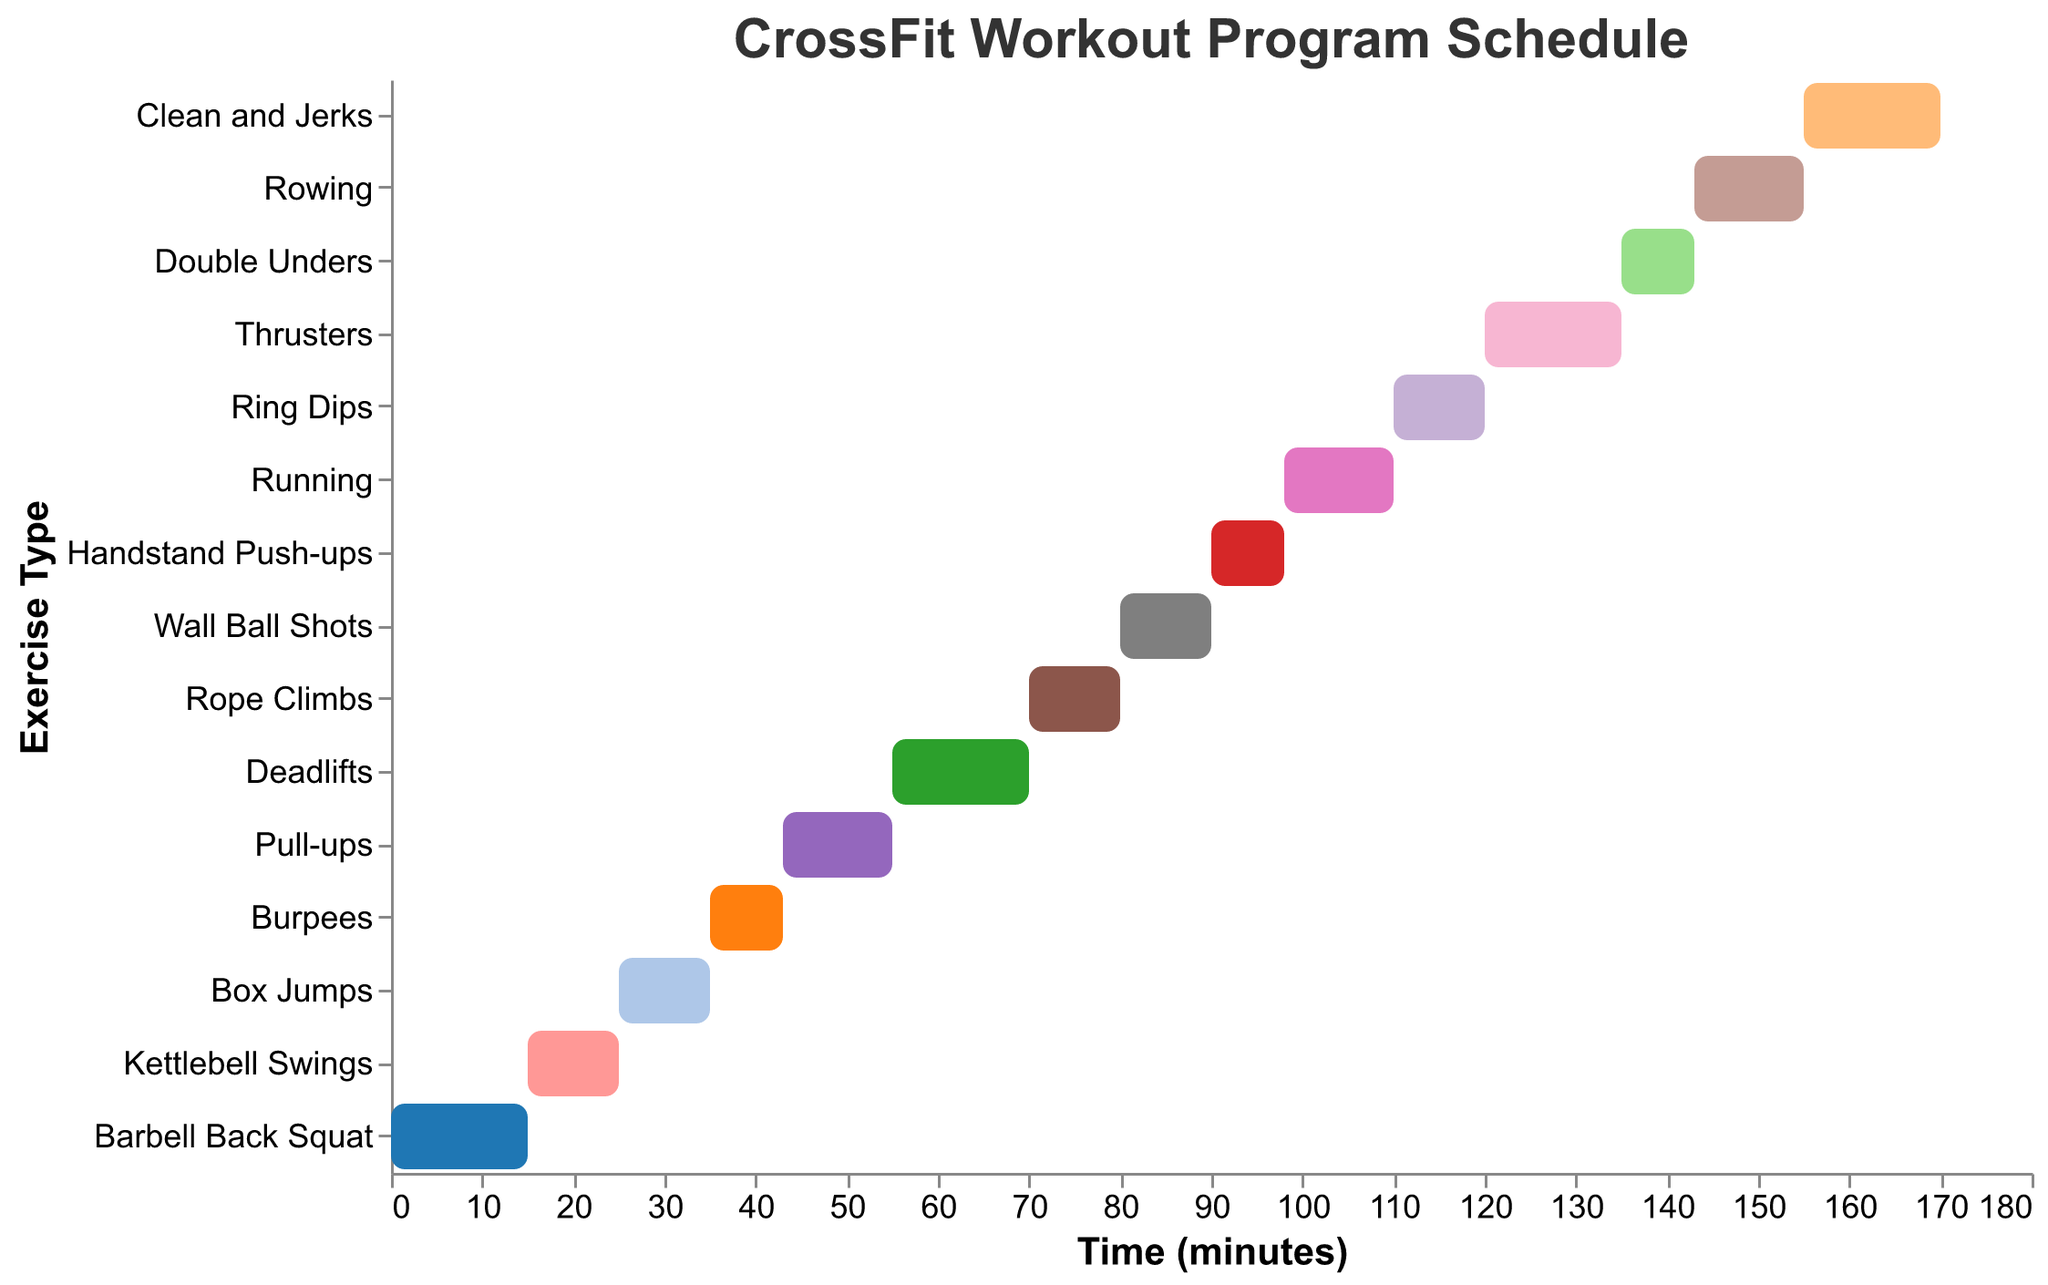What is the title of the figure? The title can be seen at the top of the chart and reads "CrossFit Workout Program Schedule".
Answer: CrossFit Workout Program Schedule What is the duration of the Deadlifts exercise? The duration is represented by the length of the bar in the chart for the Deadlifts, which is 15 minutes.
Answer: 15 minutes Which exercise starts at 55 minutes? By looking at the starting points along the x-axis, Deadlifts starts at 55 minutes.
Answer: Deadlifts How many exercises have a duration of exactly 10 minutes? The bars for exercises with 10 minutes duration are Kettlebell Swings, Box Jumps, Rope Climbs, Wall Ball Shots, and Ring Dips.
Answer: 5 Which exercise has the longest duration? Comparing the lengths of all bars, Barbell Back Squat, Deadlifts, Thrusters, and Clean and Jerks all have the longest duration of 15 minutes.
Answer: Barbell Back Squat, Deadlifts, Thrusters, Clean and Jerks What is the time gap between the end of Burpees and the start of Pull-ups? Burpees end at 43 minutes and Pull-ups start immediately after at 43 minutes, so there is no gap.
Answer: 0 minutes At what time does the Rope Climbs exercise end? Rope Climbs start at 70 minutes and have a duration of 10 minutes, so they end at 80 minutes.
Answer: 80 minutes How many exercises have a duration shorter than 10 minutes? The exercises with durations shorter than 10 minutes are Burpees, Handstand Push-ups, and Double Unders.
Answer: 3 Which exercise follows immediately after Running? By looking at the start times, Ring Dips follow Running since Running ends at 110 minutes and Ring Dips start immediately after at 110 minutes.
Answer: Ring Dips If we combine the durations of Kettlebell Swings and Box Jumps, what is the total duration? Kettlebell Swings have a duration of 10 minutes, and Box Jumps have a duration of 10 minutes, so their combined duration is 10 + 10 = 20 minutes.
Answer: 20 minutes 